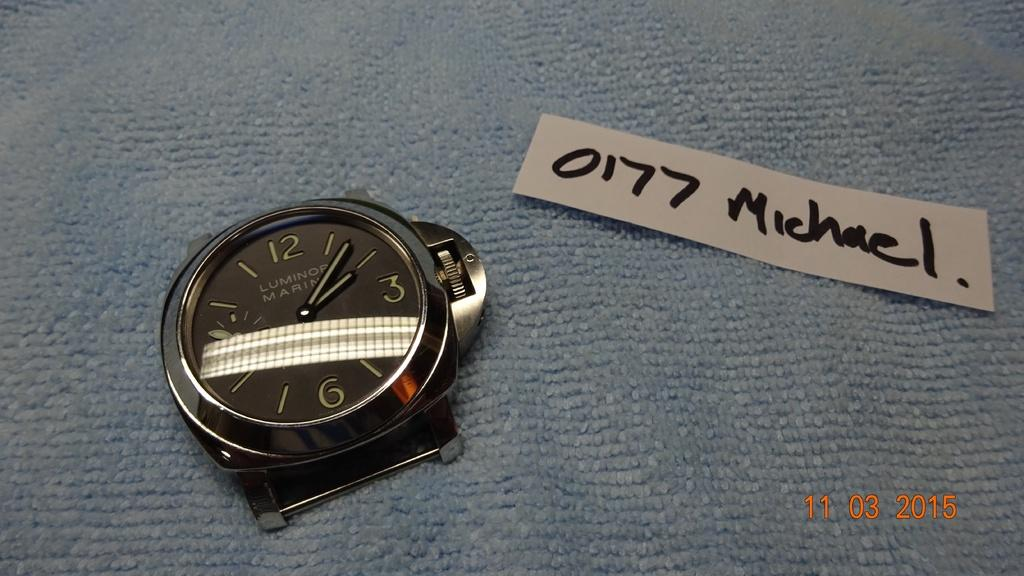<image>
Present a compact description of the photo's key features. A white "0177 Michael." is on a piece of paper next to a watch. 